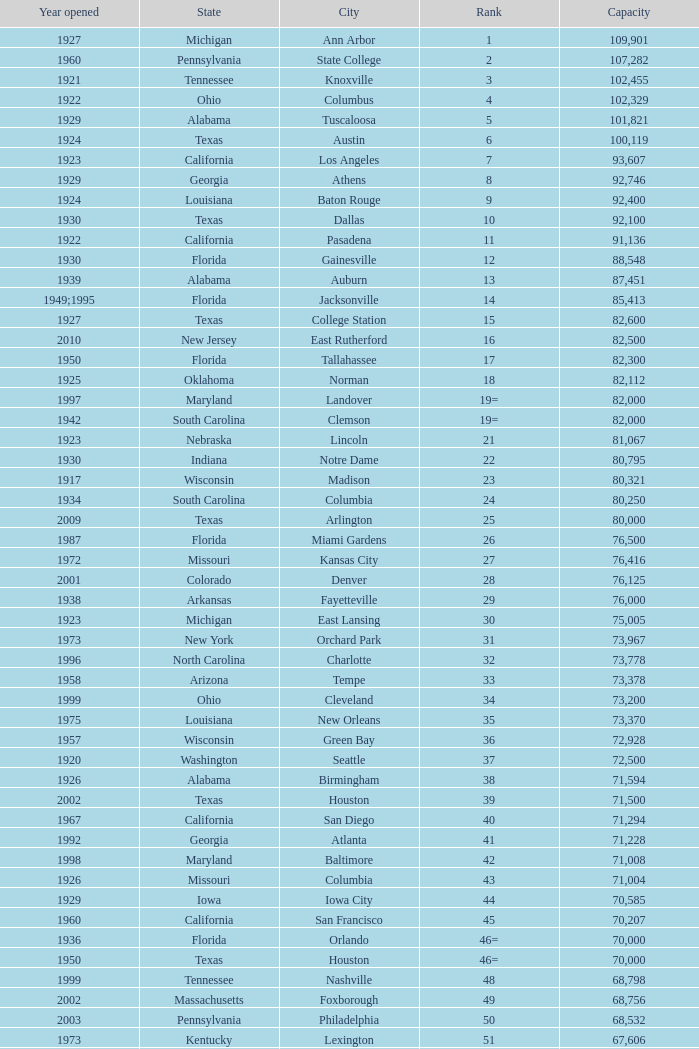What is the lowest capacity for 1903? 30323.0. 